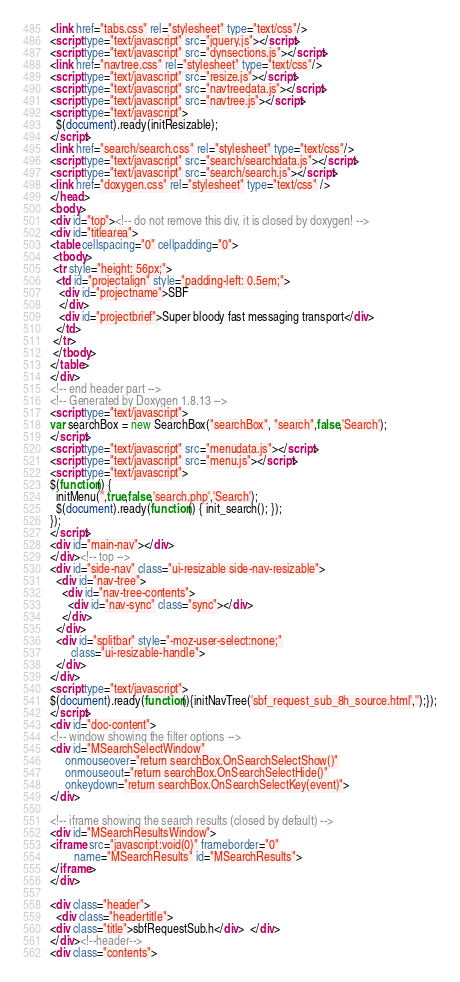<code> <loc_0><loc_0><loc_500><loc_500><_HTML_><link href="tabs.css" rel="stylesheet" type="text/css"/>
<script type="text/javascript" src="jquery.js"></script>
<script type="text/javascript" src="dynsections.js"></script>
<link href="navtree.css" rel="stylesheet" type="text/css"/>
<script type="text/javascript" src="resize.js"></script>
<script type="text/javascript" src="navtreedata.js"></script>
<script type="text/javascript" src="navtree.js"></script>
<script type="text/javascript">
  $(document).ready(initResizable);
</script>
<link href="search/search.css" rel="stylesheet" type="text/css"/>
<script type="text/javascript" src="search/searchdata.js"></script>
<script type="text/javascript" src="search/search.js"></script>
<link href="doxygen.css" rel="stylesheet" type="text/css" />
</head>
<body>
<div id="top"><!-- do not remove this div, it is closed by doxygen! -->
<div id="titlearea">
<table cellspacing="0" cellpadding="0">
 <tbody>
 <tr style="height: 56px;">
  <td id="projectalign" style="padding-left: 0.5em;">
   <div id="projectname">SBF
   </div>
   <div id="projectbrief">Super bloody fast messaging transport</div>
  </td>
 </tr>
 </tbody>
</table>
</div>
<!-- end header part -->
<!-- Generated by Doxygen 1.8.13 -->
<script type="text/javascript">
var searchBox = new SearchBox("searchBox", "search",false,'Search');
</script>
<script type="text/javascript" src="menudata.js"></script>
<script type="text/javascript" src="menu.js"></script>
<script type="text/javascript">
$(function() {
  initMenu('',true,false,'search.php','Search');
  $(document).ready(function() { init_search(); });
});
</script>
<div id="main-nav"></div>
</div><!-- top -->
<div id="side-nav" class="ui-resizable side-nav-resizable">
  <div id="nav-tree">
    <div id="nav-tree-contents">
      <div id="nav-sync" class="sync"></div>
    </div>
  </div>
  <div id="splitbar" style="-moz-user-select:none;" 
       class="ui-resizable-handle">
  </div>
</div>
<script type="text/javascript">
$(document).ready(function(){initNavTree('sbf_request_sub_8h_source.html','');});
</script>
<div id="doc-content">
<!-- window showing the filter options -->
<div id="MSearchSelectWindow"
     onmouseover="return searchBox.OnSearchSelectShow()"
     onmouseout="return searchBox.OnSearchSelectHide()"
     onkeydown="return searchBox.OnSearchSelectKey(event)">
</div>

<!-- iframe showing the search results (closed by default) -->
<div id="MSearchResultsWindow">
<iframe src="javascript:void(0)" frameborder="0" 
        name="MSearchResults" id="MSearchResults">
</iframe>
</div>

<div class="header">
  <div class="headertitle">
<div class="title">sbfRequestSub.h</div>  </div>
</div><!--header-->
<div class="contents"></code> 